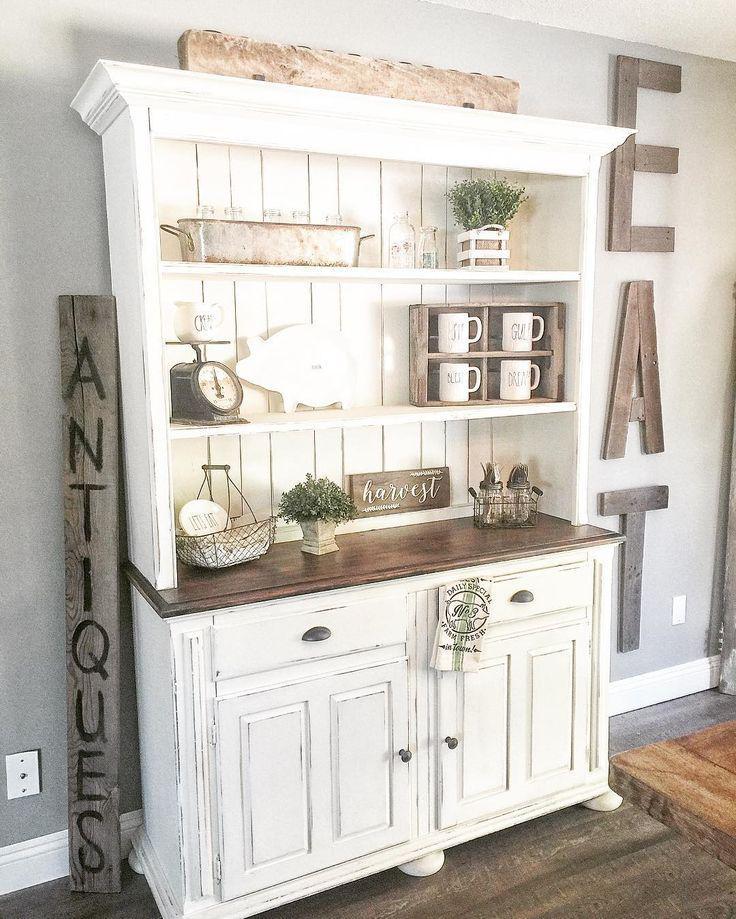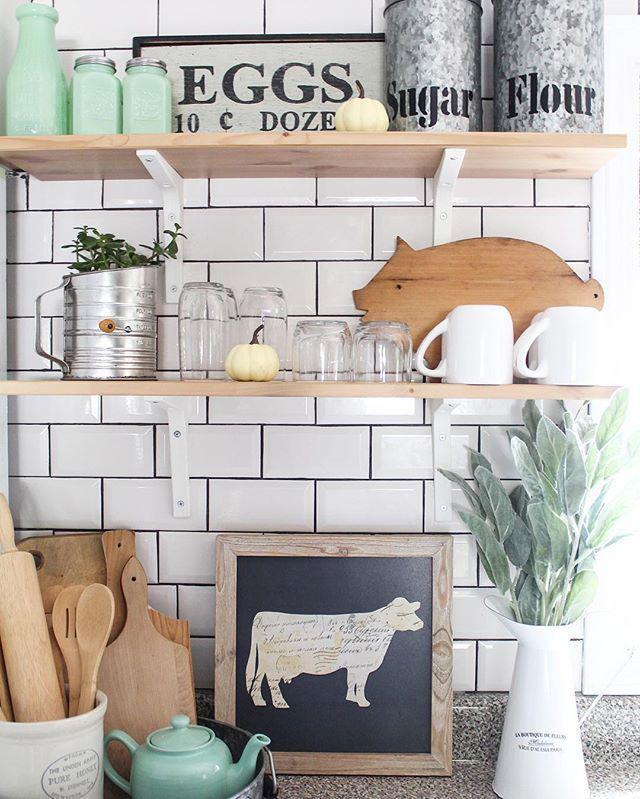The first image is the image on the left, the second image is the image on the right. Assess this claim about the two images: "At least one image shows floating brown shelves, and all images include at least one potted green plant.". Correct or not? Answer yes or no. Yes. 